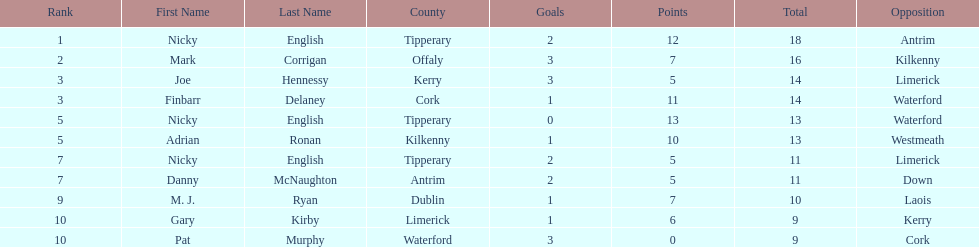Which player ranked the most? Nicky English. 